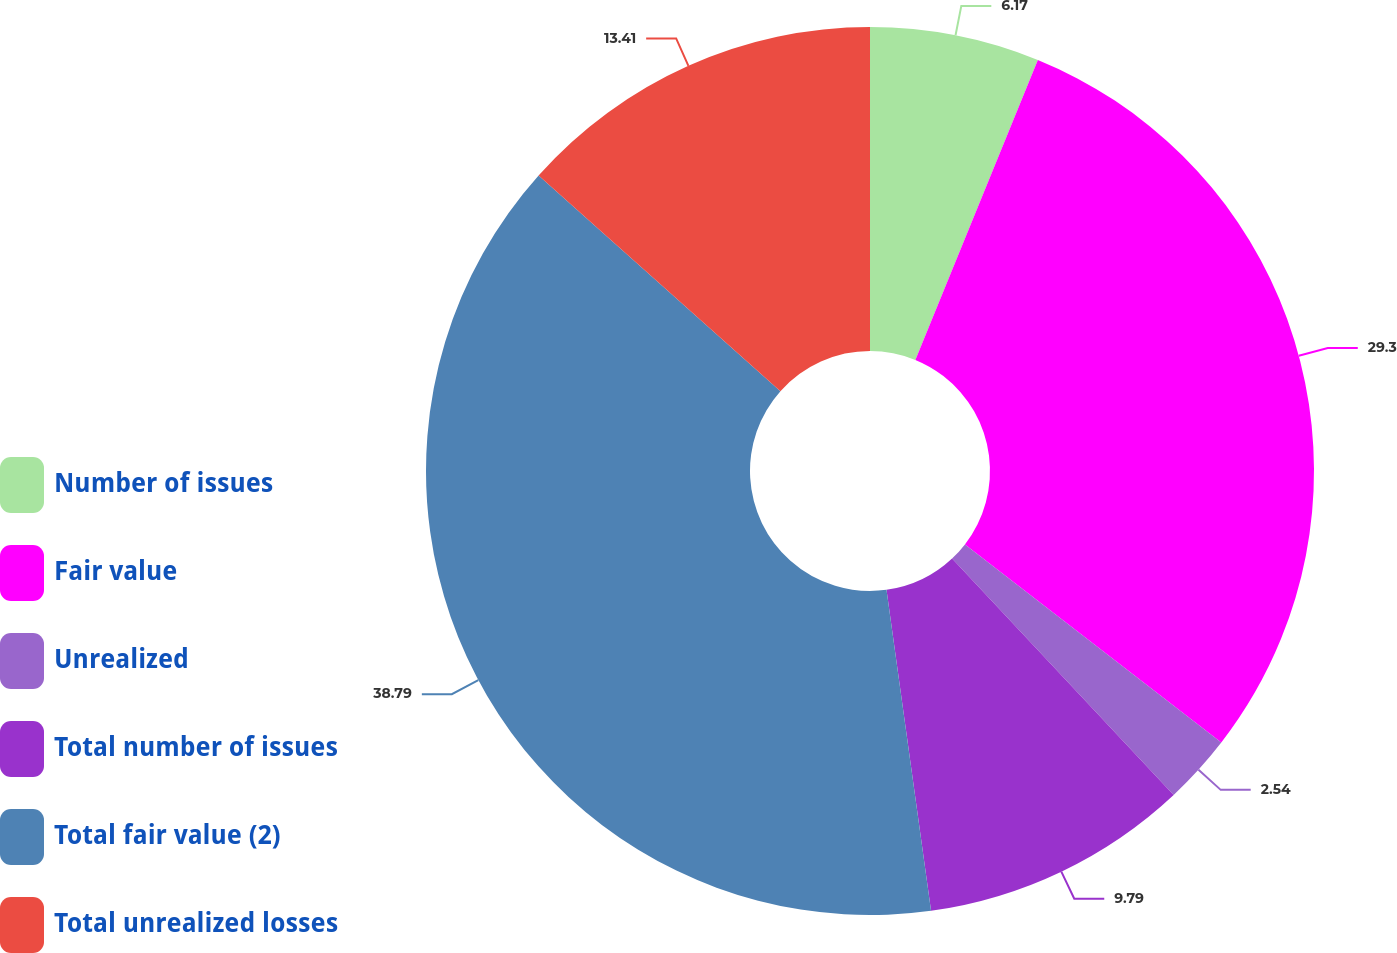Convert chart to OTSL. <chart><loc_0><loc_0><loc_500><loc_500><pie_chart><fcel>Number of issues<fcel>Fair value<fcel>Unrealized<fcel>Total number of issues<fcel>Total fair value (2)<fcel>Total unrealized losses<nl><fcel>6.17%<fcel>29.3%<fcel>2.54%<fcel>9.79%<fcel>38.78%<fcel>13.41%<nl></chart> 